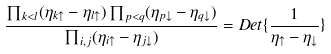<formula> <loc_0><loc_0><loc_500><loc_500>\frac { \prod _ { k < l } ( \eta _ { k \uparrow } - \eta _ { l \uparrow } ) \prod _ { p < q } ( \eta _ { p \downarrow } - \eta _ { q \downarrow } ) } { \prod _ { i , j } ( \eta _ { i \uparrow } - \eta _ { j \downarrow } ) } = D e t \{ \frac { 1 } { \eta _ { \uparrow } - \eta _ { \downarrow } } \}</formula> 